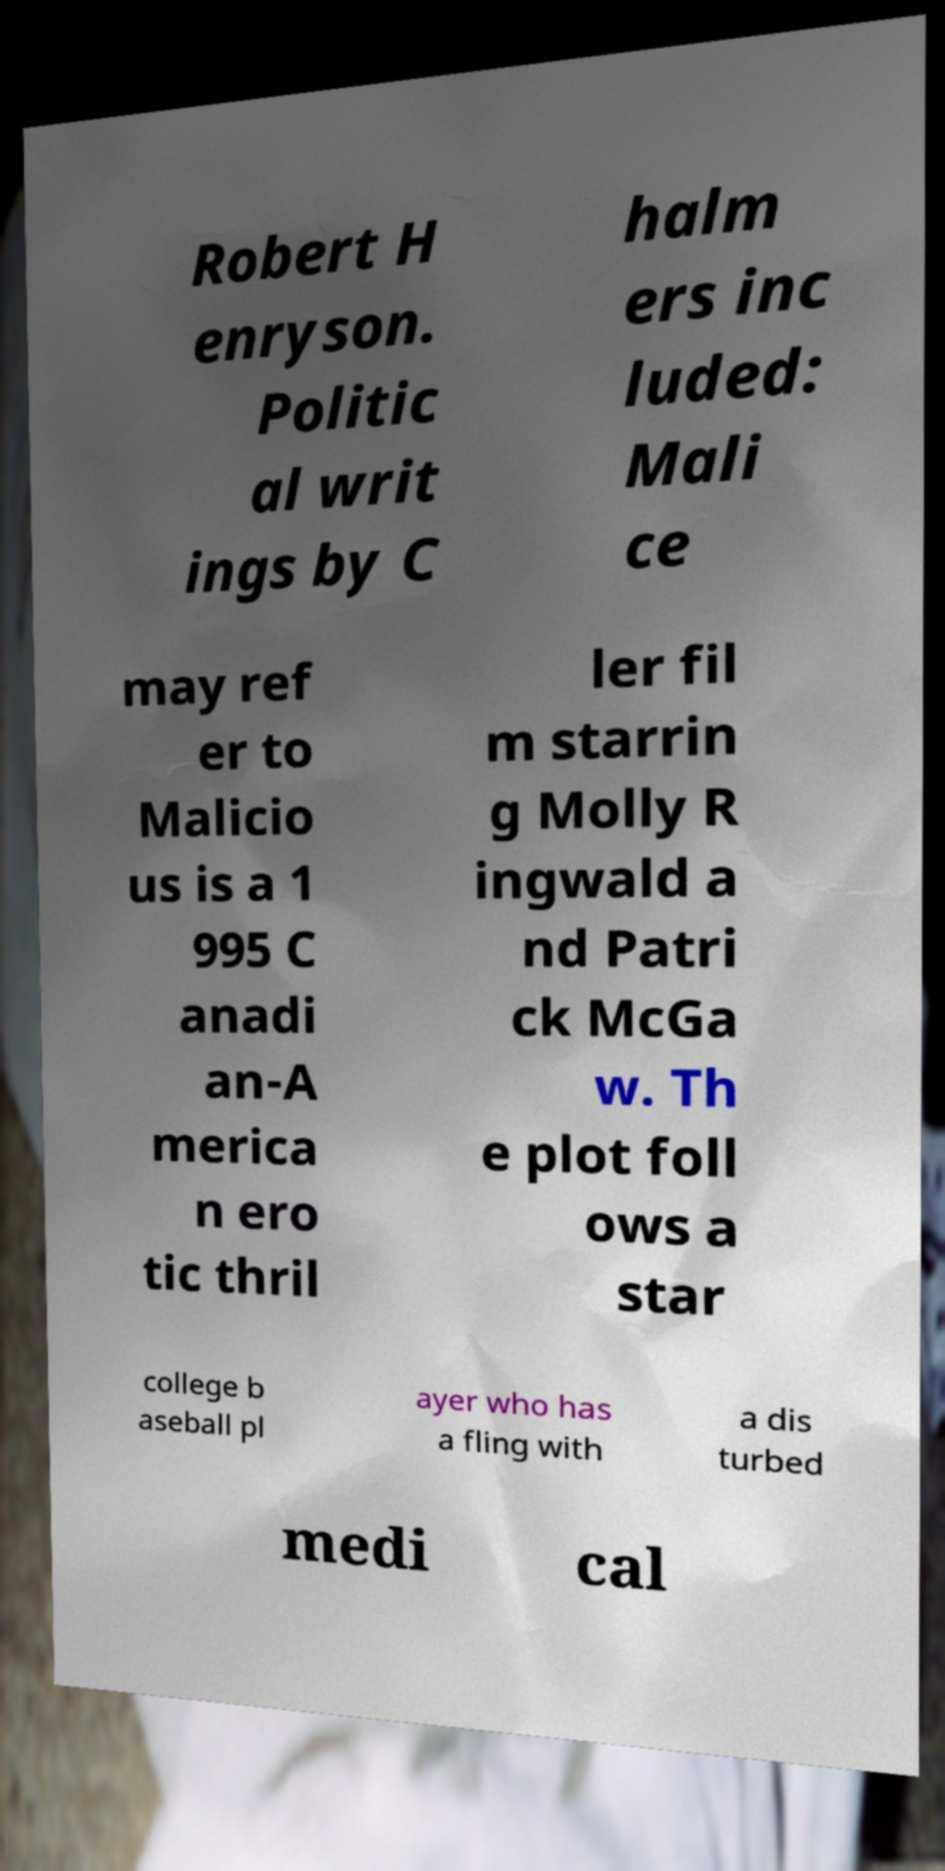There's text embedded in this image that I need extracted. Can you transcribe it verbatim? Robert H enryson. Politic al writ ings by C halm ers inc luded: Mali ce may ref er to Malicio us is a 1 995 C anadi an-A merica n ero tic thril ler fil m starrin g Molly R ingwald a nd Patri ck McGa w. Th e plot foll ows a star college b aseball pl ayer who has a fling with a dis turbed medi cal 